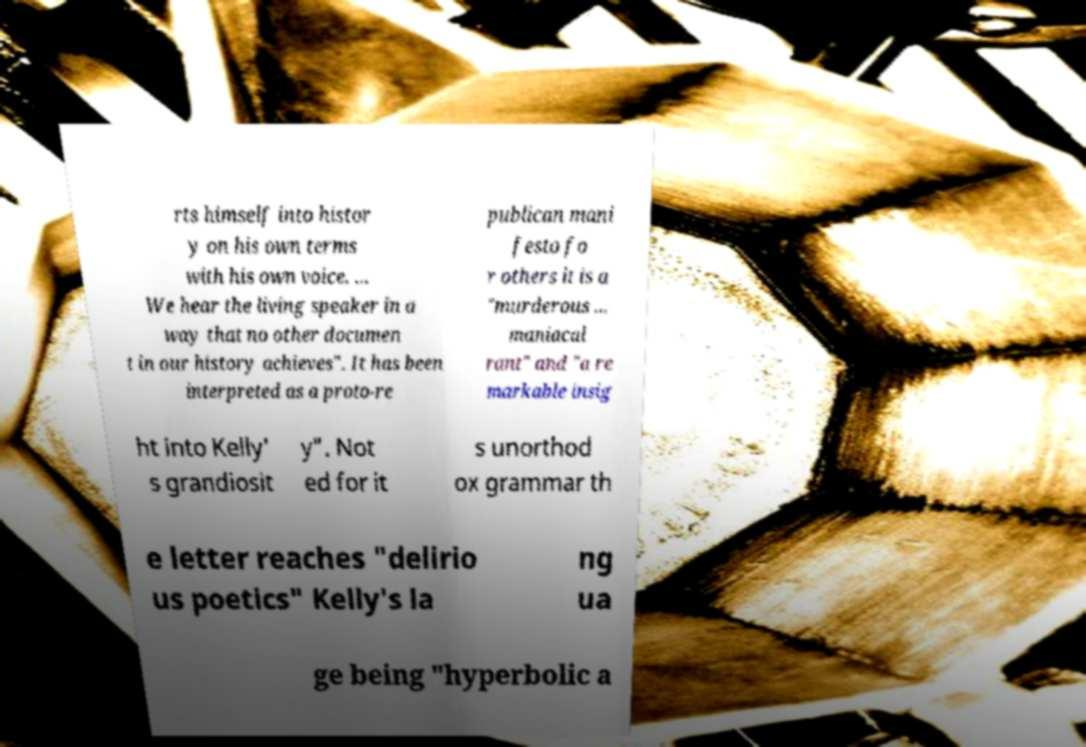Please read and relay the text visible in this image. What does it say? rts himself into histor y on his own terms with his own voice. ... We hear the living speaker in a way that no other documen t in our history achieves". It has been interpreted as a proto-re publican mani festo fo r others it is a "murderous ... maniacal rant" and "a re markable insig ht into Kelly' s grandiosit y". Not ed for it s unorthod ox grammar th e letter reaches "delirio us poetics" Kelly's la ng ua ge being "hyperbolic a 